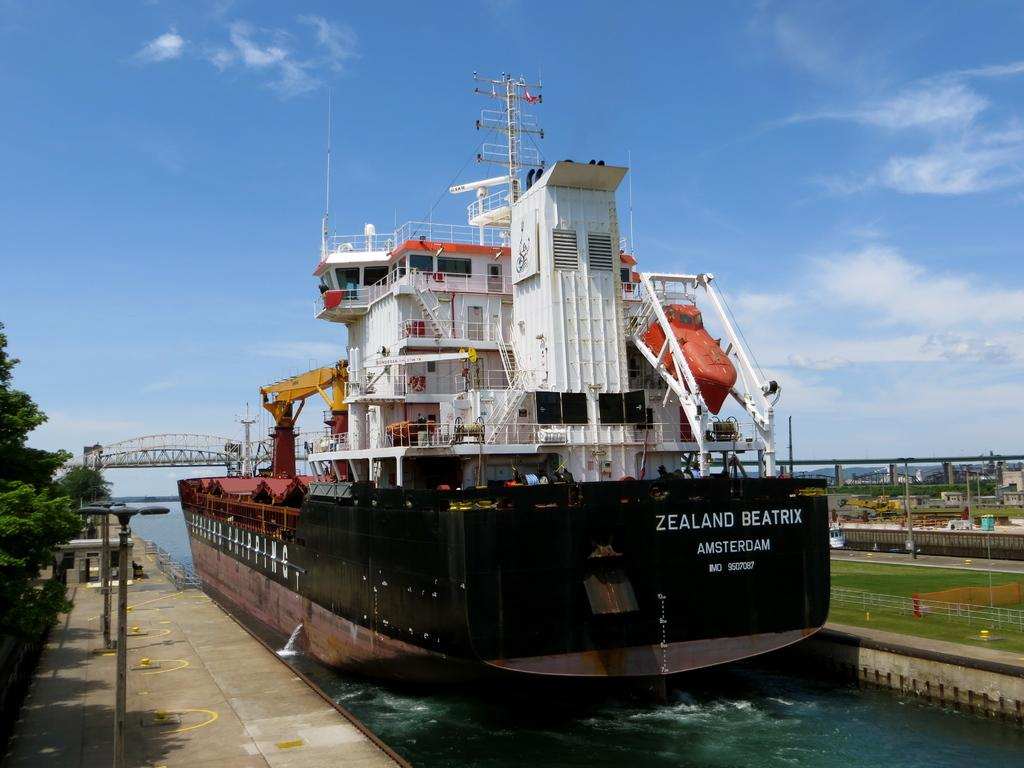Provide a one-sentence caption for the provided image. The Zealand Beatrix Ship is docked in the harbor. 